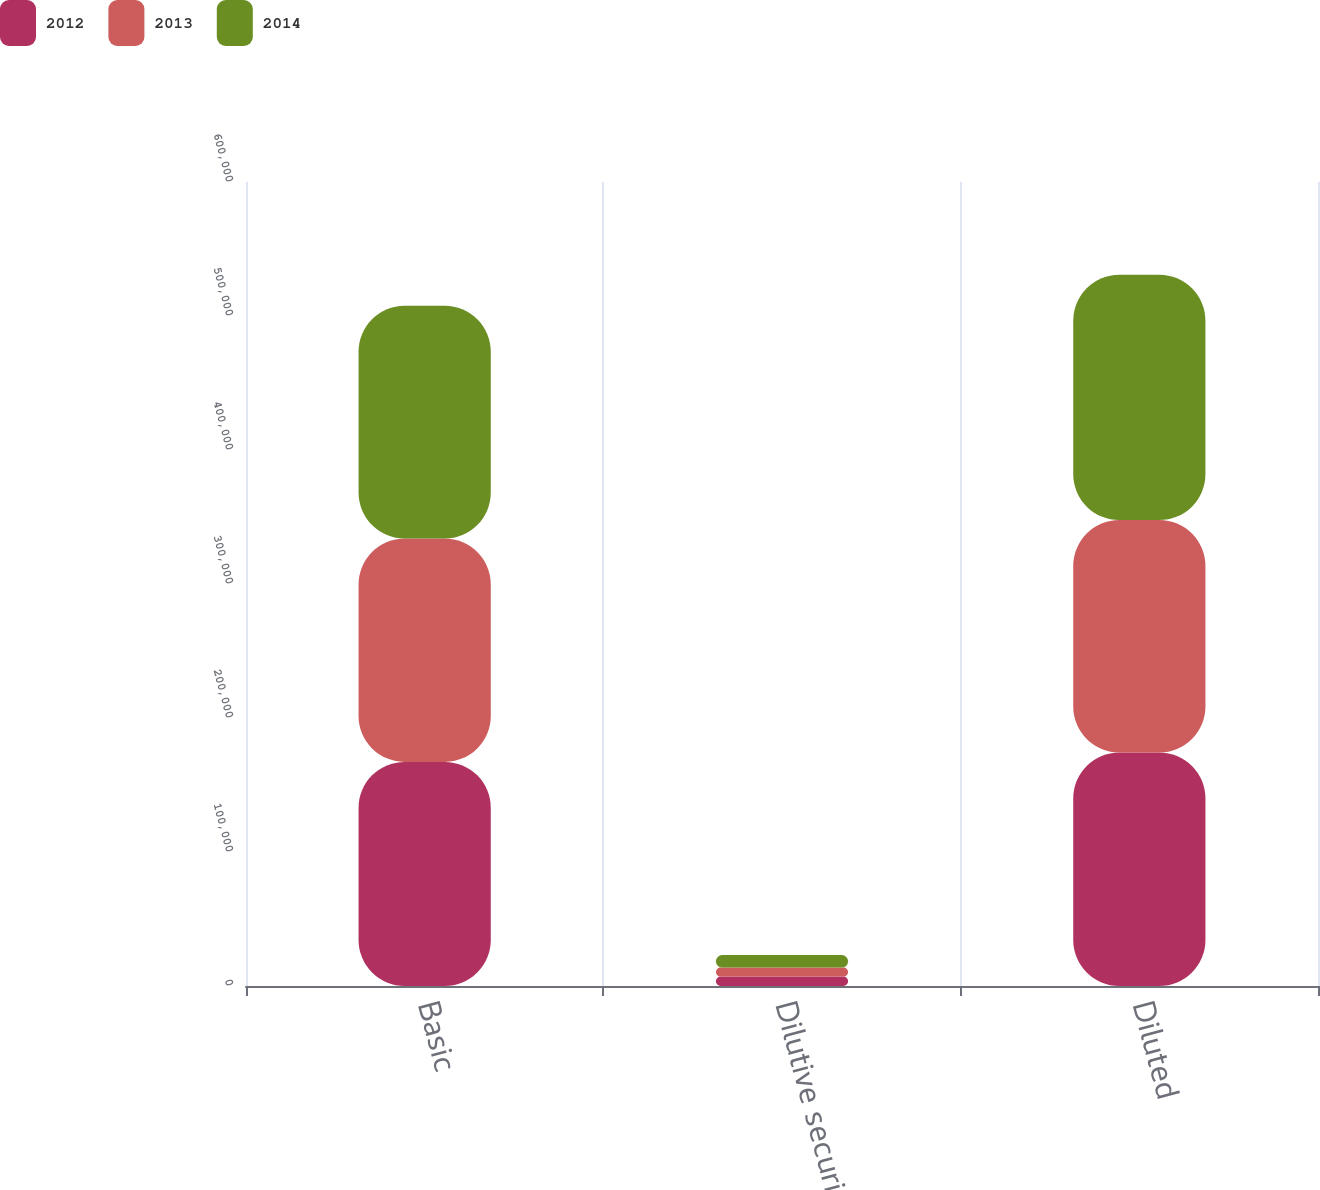Convert chart. <chart><loc_0><loc_0><loc_500><loc_500><stacked_bar_chart><ecel><fcel>Basic<fcel>Dilutive securities<fcel>Diluted<nl><fcel>2012<fcel>167257<fcel>7028<fcel>174285<nl><fcel>2013<fcel>166679<fcel>6708<fcel>173387<nl><fcel>2014<fcel>173712<fcel>9371<fcel>183083<nl></chart> 